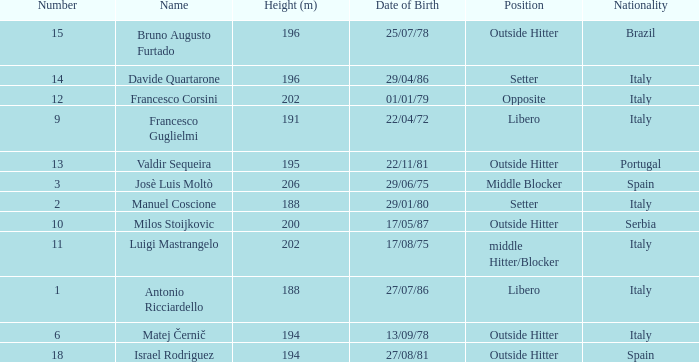Name the least number 1.0. 